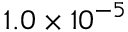<formula> <loc_0><loc_0><loc_500><loc_500>1 . 0 \times 1 0 ^ { - 5 }</formula> 